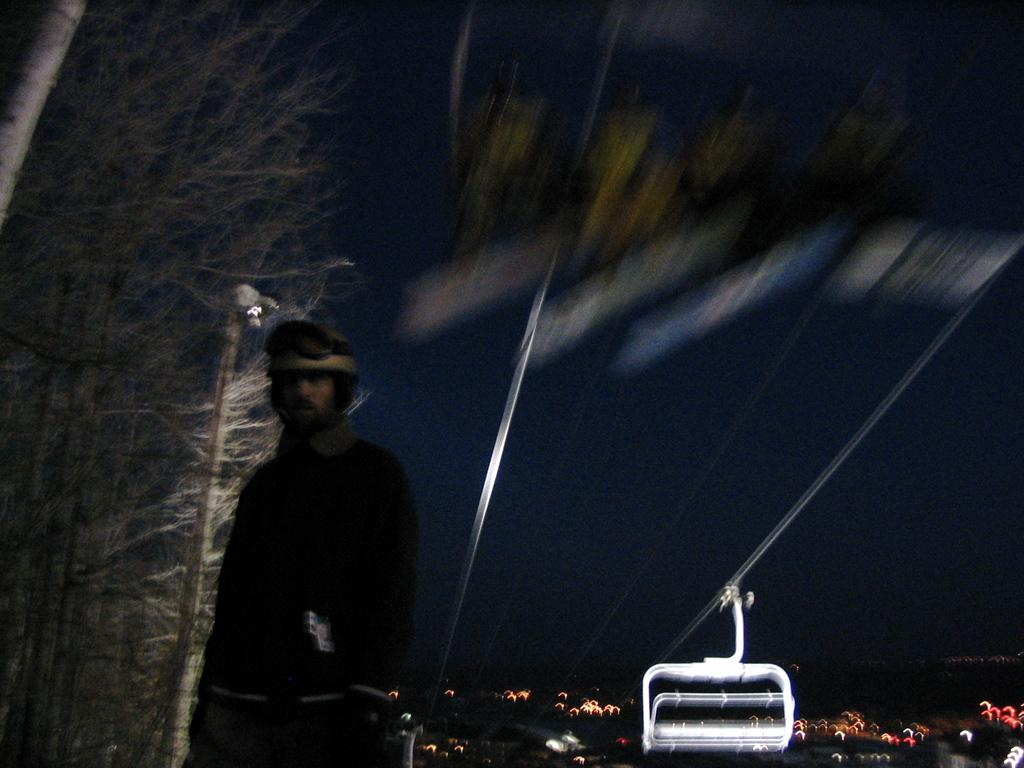What is the main subject in the foreground of the image? There is a person standing in the foreground of the image. What mode of transportation can be seen in the image? There is a cable car in the image. What are the wires in the image used for? The wires in the image are likely used for supporting the cable car. What type of structures can be seen in the background of the image? There are buildings in the background of the image. What additional features can be observed in the background of the image? Lights, trees, and poles are visible in the background of the image. What type of button is being used to control the net in the image? There is no button or net present in the image. 